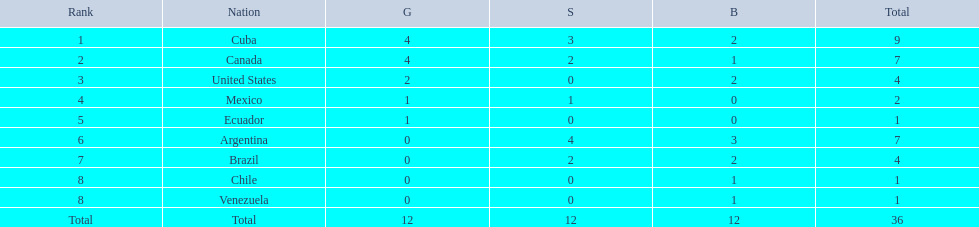What countries participated? Cuba, 4, 3, 2, Canada, 4, 2, 1, United States, 2, 0, 2, Mexico, 1, 1, 0, Ecuador, 1, 0, 0, Argentina, 0, 4, 3, Brazil, 0, 2, 2, Chile, 0, 0, 1, Venezuela, 0, 0, 1. What countries won 1 gold Mexico, 1, 1, 0, Ecuador, 1, 0, 0. What country above also won no silver? Ecuador. 